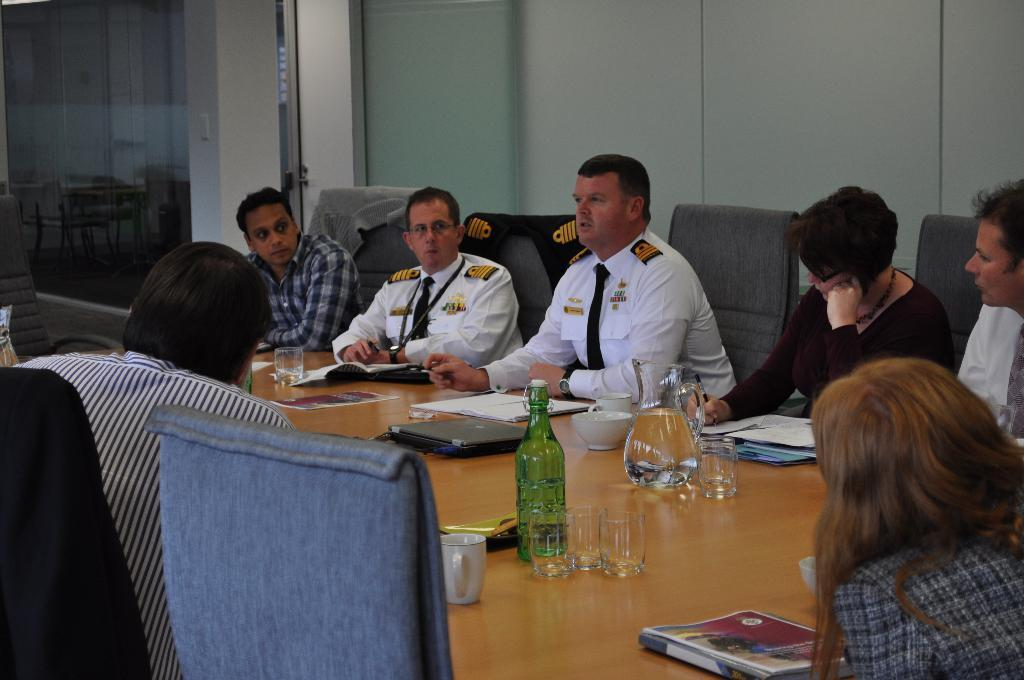What are the people in the image doing? The people in the image are sitting around a table. What objects can be seen on the table? There are glasses, books, cups, laptops, and files on the table. Can you describe the door visible at the back of the image? There is a door visible at the back of the image. What type of brick is being used to build the pail in the image? There is no brick or pail present in the image. Is this a formal meeting or a casual gathering? The image does not provide any information about the nature of the gathering, so it cannot be determined whether it is a formal meeting or a casual gathering. 